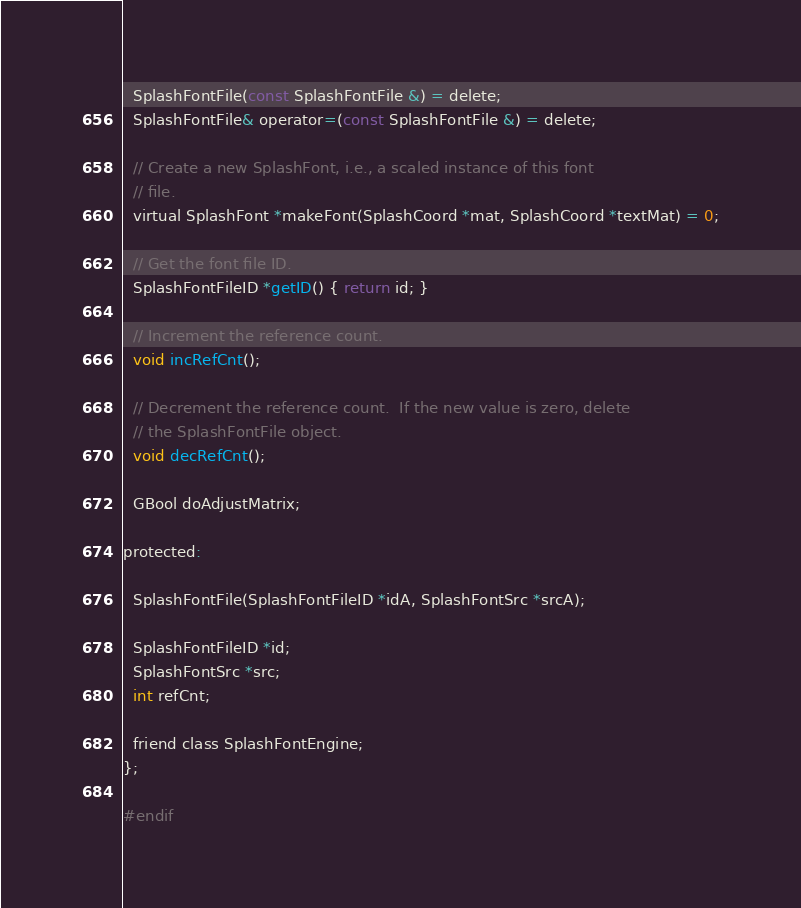<code> <loc_0><loc_0><loc_500><loc_500><_C_>
  SplashFontFile(const SplashFontFile &) = delete;
  SplashFontFile& operator=(const SplashFontFile &) = delete;

  // Create a new SplashFont, i.e., a scaled instance of this font
  // file.
  virtual SplashFont *makeFont(SplashCoord *mat, SplashCoord *textMat) = 0;

  // Get the font file ID.
  SplashFontFileID *getID() { return id; }

  // Increment the reference count.
  void incRefCnt();

  // Decrement the reference count.  If the new value is zero, delete
  // the SplashFontFile object.
  void decRefCnt();

  GBool doAdjustMatrix;

protected:

  SplashFontFile(SplashFontFileID *idA, SplashFontSrc *srcA);

  SplashFontFileID *id;
  SplashFontSrc *src;
  int refCnt;

  friend class SplashFontEngine;
};

#endif
</code> 